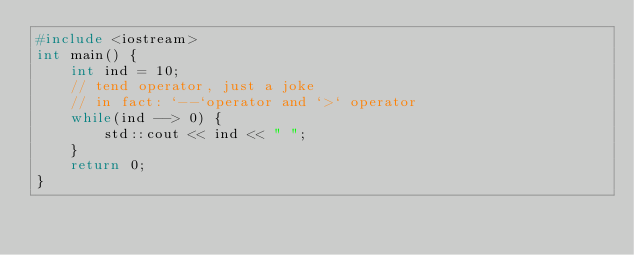<code> <loc_0><loc_0><loc_500><loc_500><_C++_>#include <iostream>
int main() {
	int ind = 10;
	// tend operator, just a joke
	// in fact: `--`operator and `>` operator
	while(ind --> 0) {
		std::cout << ind << " ";
	}
	return 0;
}
</code> 